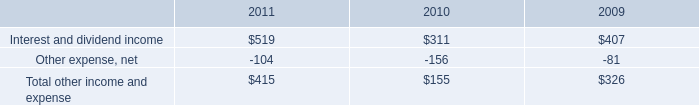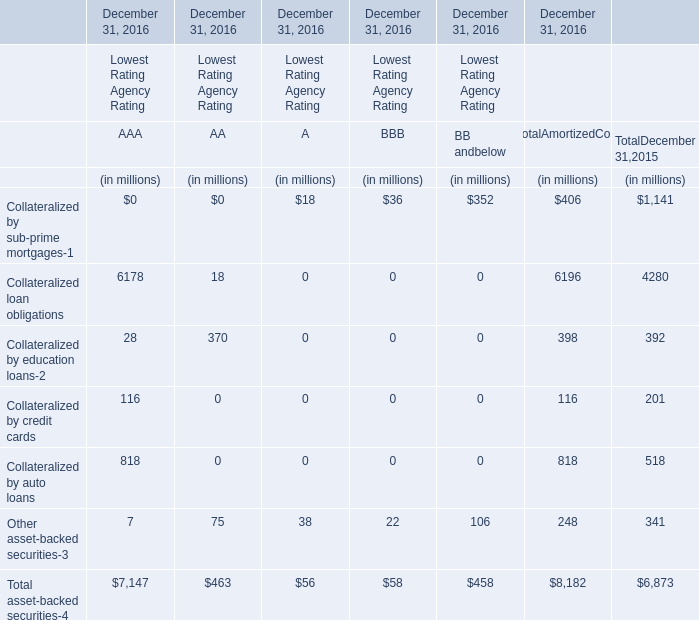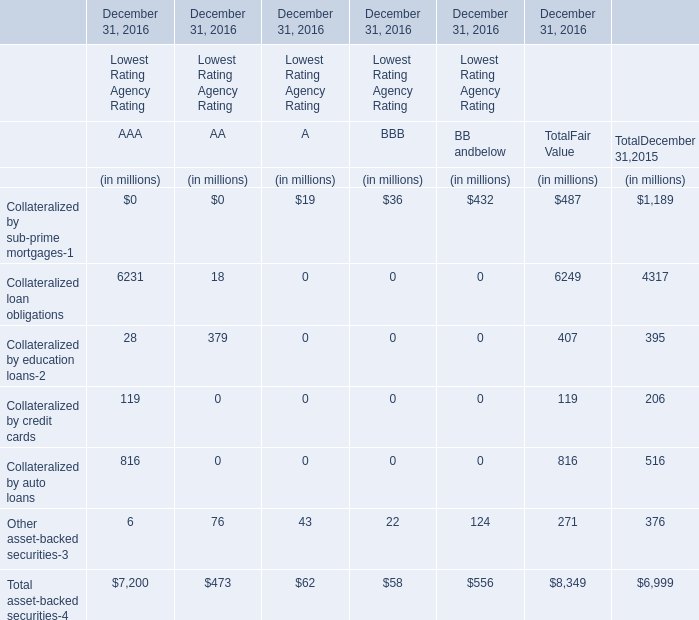What's the greatest value of Collateralized loan obligations in 2006 for AAA and AA? (in million) 
Computations: (6231 + 18)
Answer: 6249.0. 